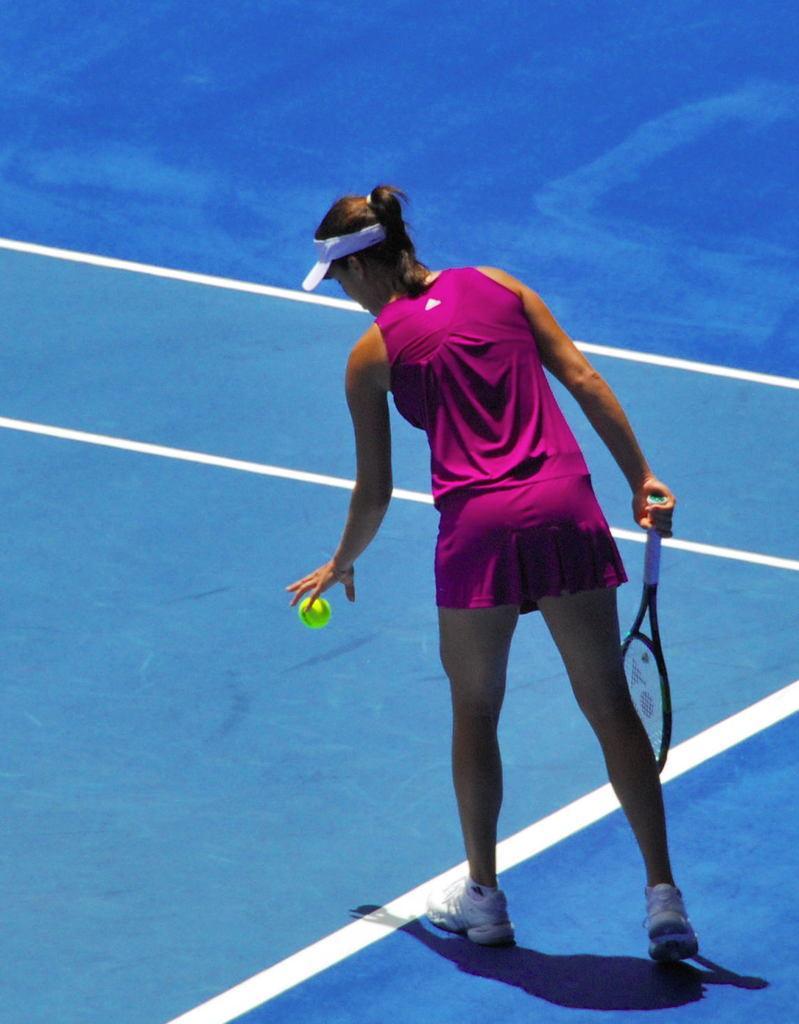Could you give a brief overview of what you see in this image? in this image the woman is playing the tennis and wearing some pink color skirt and shirt and hat and shoes and the background is very sunny. 